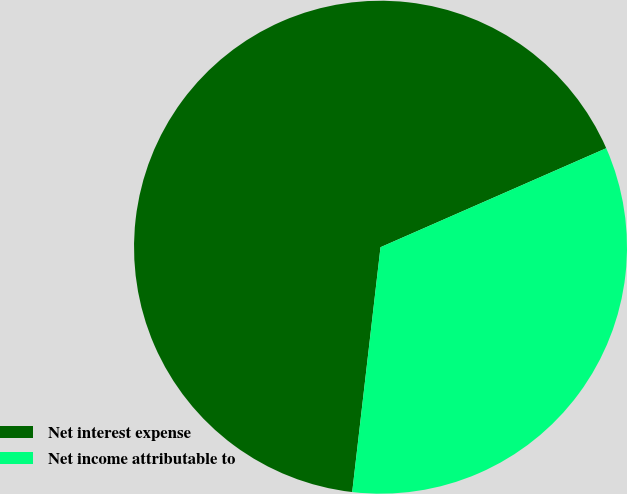<chart> <loc_0><loc_0><loc_500><loc_500><pie_chart><fcel>Net interest expense<fcel>Net income attributable to<nl><fcel>66.59%<fcel>33.41%<nl></chart> 